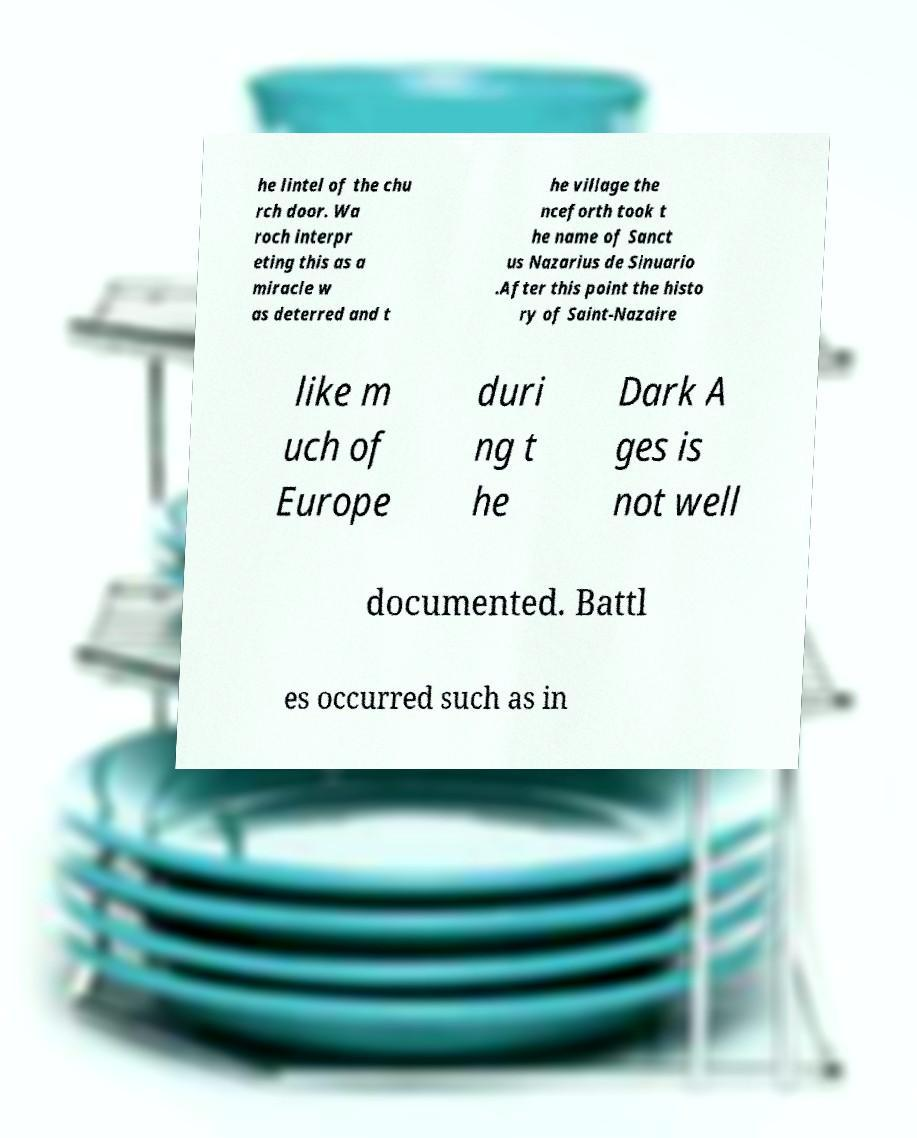Can you read and provide the text displayed in the image?This photo seems to have some interesting text. Can you extract and type it out for me? he lintel of the chu rch door. Wa roch interpr eting this as a miracle w as deterred and t he village the nceforth took t he name of Sanct us Nazarius de Sinuario .After this point the histo ry of Saint-Nazaire like m uch of Europe duri ng t he Dark A ges is not well documented. Battl es occurred such as in 